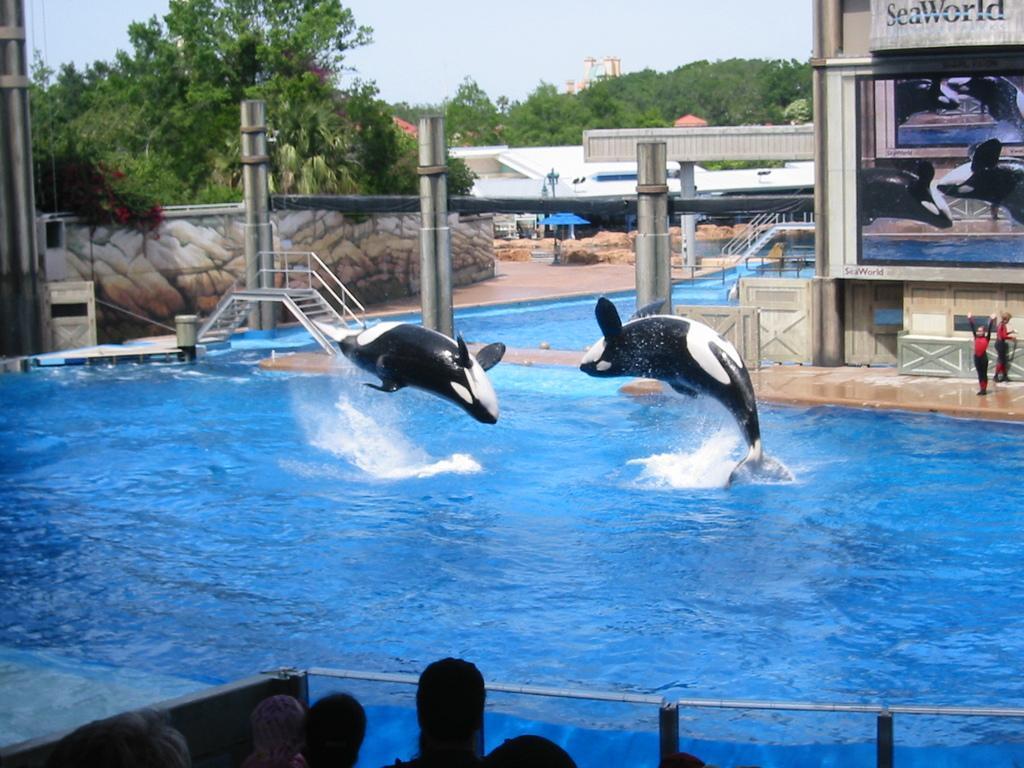In one or two sentences, can you explain what this image depicts? In this image at the bottom we can see few persons heads, fence, water, two dolphins in the air above the water, poles, steps, boards on the wall, two persons are standing on the platform, trees and sky. 